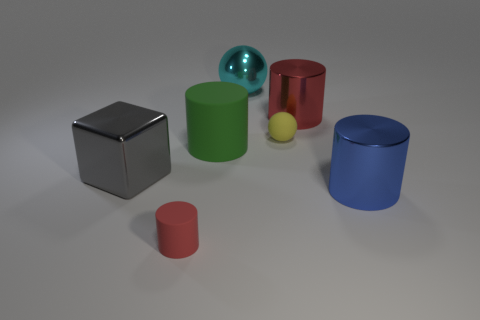Add 3 big cylinders. How many objects exist? 10 Subtract all cylinders. How many objects are left? 3 Add 4 purple metallic cylinders. How many purple metallic cylinders exist? 4 Subtract 0 red spheres. How many objects are left? 7 Subtract all small purple metallic cubes. Subtract all big green matte objects. How many objects are left? 6 Add 4 large cyan objects. How many large cyan objects are left? 5 